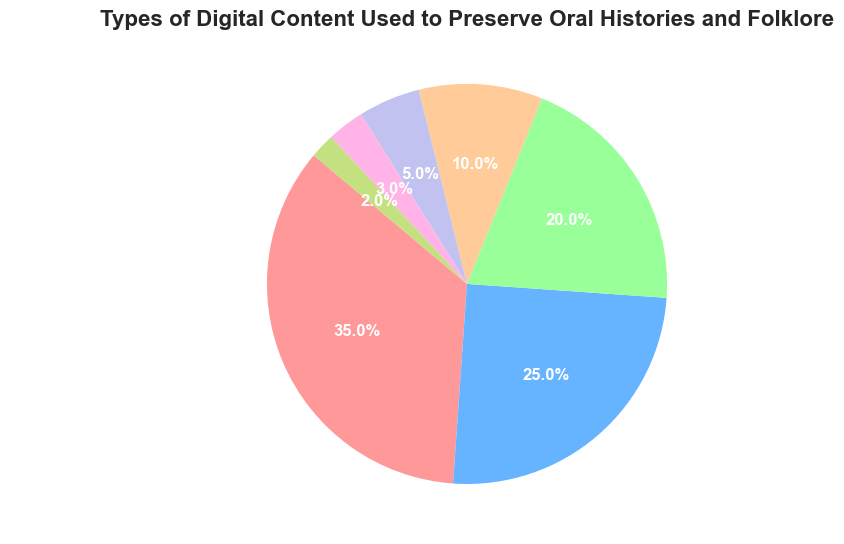How many more percentage points do videos have compared to podcasts? To find this, subtract the percentage for podcasts from the percentage for videos: 35% - 25% = 10%.
Answer: 10 Which type of digital content has the smallest percentage? By looking at the pie chart, the smallest segment corresponds to Augmented Reality Experiences at 2%.
Answer: Augmented Reality Experiences What is the total percentage of Written Narratives and Interactive Websites combined? Add the percentages of Written Narratives and Interactive Websites: 20% + 5% = 25%.
Answer: 25% Which color represents Digital Story Maps on the pie chart? Digital Story Maps correspond to the segment colored in light orange.
Answer: Light orange Are Social Media Posts used less frequently than Digital Story Maps? Yes, by comparing the percentages, Social Media Posts (3%) are less frequent than Digital Story Maps (10%).
Answer: Yes What is the total coverage of all types of digital content except Videos? Subtract the percentage for Videos from 100%: 100% - 35% = 65%.
Answer: 65% Which digital content type has the second-highest percentage? The second-largest segment by percentage is Podcasts at 25%.
Answer: Podcasts Is the percentage of Podcasts and Written Narratives combined greater than that of Videos? Add the percentages of Podcasts and Written Narratives and compare with Videos: 25% + 20% = 45%, which is greater than 35%.
Answer: Yes What is the total percentage of all content types that are less than 10%? Sum percentages of Interactive Websites, Social Media Posts, and Augmented Reality Experiences: 5% + 3% + 2% = 10%.
Answer: 10% How many types of digital content have a percentage greater than 20%? By visually inspecting the segments, two types (Videos and Podcasts) have percentages greater than 20%.
Answer: 2 